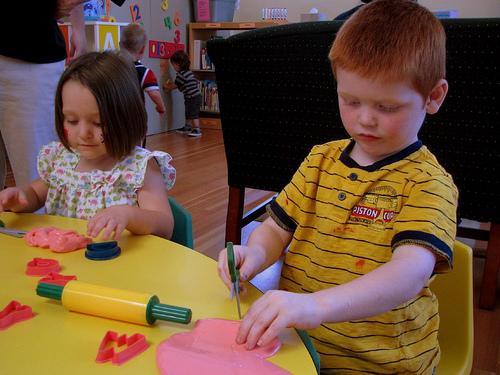What are the children playing with?
Be succinct. Play-doh. What grade are the children in?
Answer briefly. Kindergarten. Is the boy playing with cars?
Write a very short answer. No. Are the people celebrating?
Be succinct. No. 